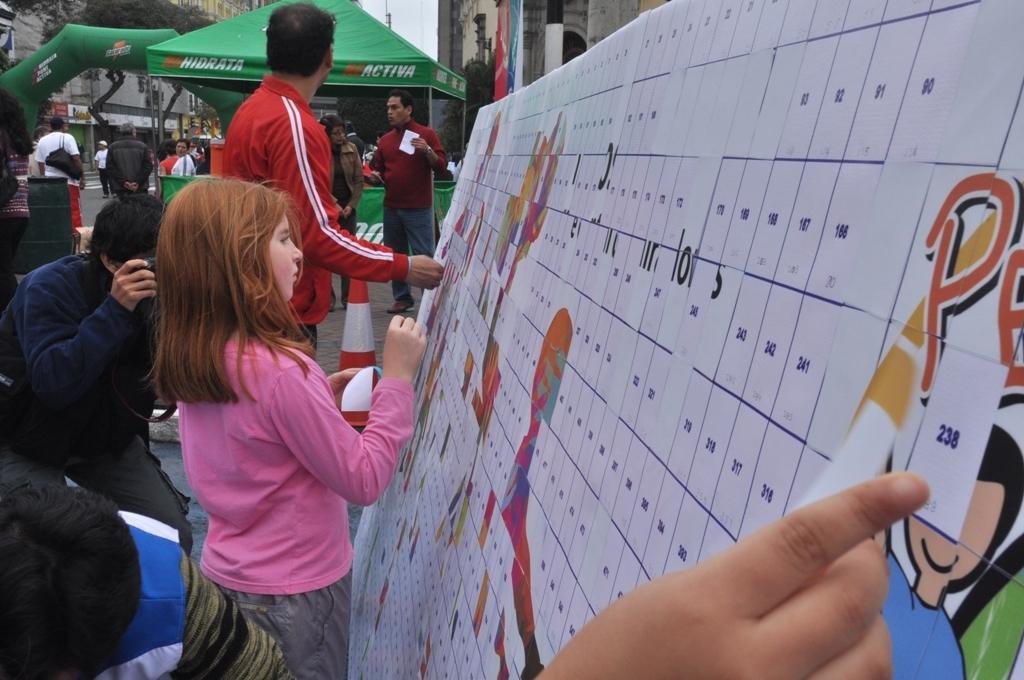In one or two sentences, can you explain what this image depicts? On the right side of the image there are buildings, in front of the building there is a board with some images and text on it, in front of that, there are a few people standing and placing something on it, one of them is holding the camera and taking pictures. Behind them there is a camp, beneath the camp there are a few people standing and few are walking on the floor. In the background there are buildings, trees and the sky. 